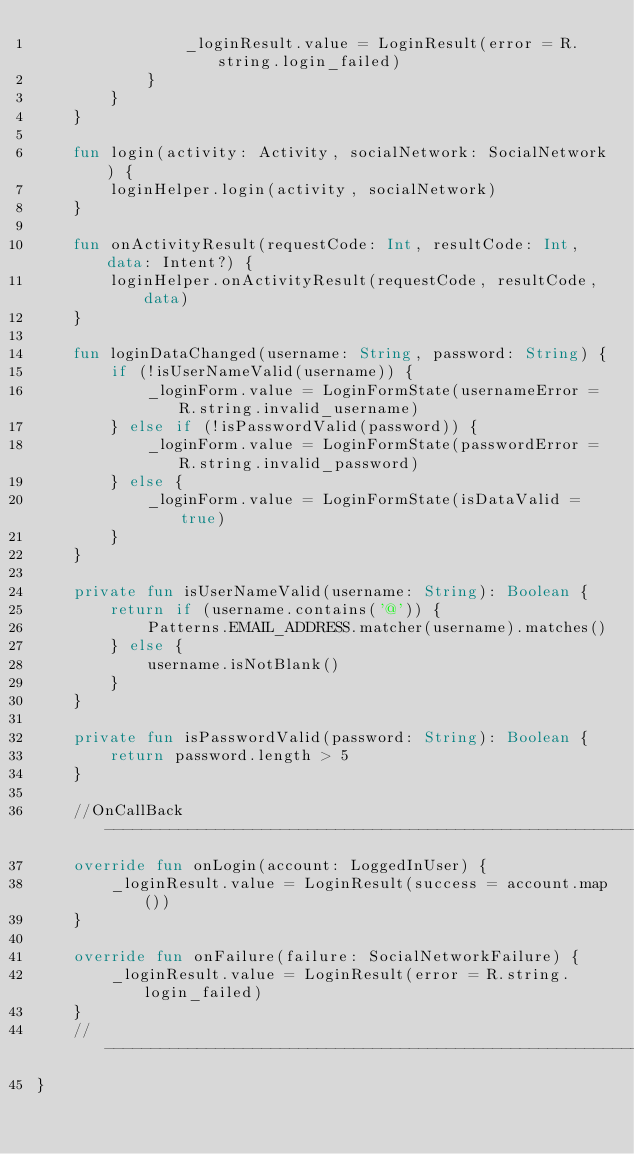<code> <loc_0><loc_0><loc_500><loc_500><_Kotlin_>                _loginResult.value = LoginResult(error = R.string.login_failed)
            }
        }
    }

    fun login(activity: Activity, socialNetwork: SocialNetwork) {
        loginHelper.login(activity, socialNetwork)
    }

    fun onActivityResult(requestCode: Int, resultCode: Int, data: Intent?) {
        loginHelper.onActivityResult(requestCode, resultCode, data)
    }

    fun loginDataChanged(username: String, password: String) {
        if (!isUserNameValid(username)) {
            _loginForm.value = LoginFormState(usernameError = R.string.invalid_username)
        } else if (!isPasswordValid(password)) {
            _loginForm.value = LoginFormState(passwordError = R.string.invalid_password)
        } else {
            _loginForm.value = LoginFormState(isDataValid = true)
        }
    }

    private fun isUserNameValid(username: String): Boolean {
        return if (username.contains('@')) {
            Patterns.EMAIL_ADDRESS.matcher(username).matches()
        } else {
            username.isNotBlank()
        }
    }

    private fun isPasswordValid(password: String): Boolean {
        return password.length > 5
    }

    //OnCallBack ---------------------------------------------------------------
    override fun onLogin(account: LoggedInUser) {
        _loginResult.value = LoginResult(success = account.map())
    }

    override fun onFailure(failure: SocialNetworkFailure) {
        _loginResult.value = LoginResult(error = R.string.login_failed)
    }
    //--------------------------------------------------------------------------
}
</code> 